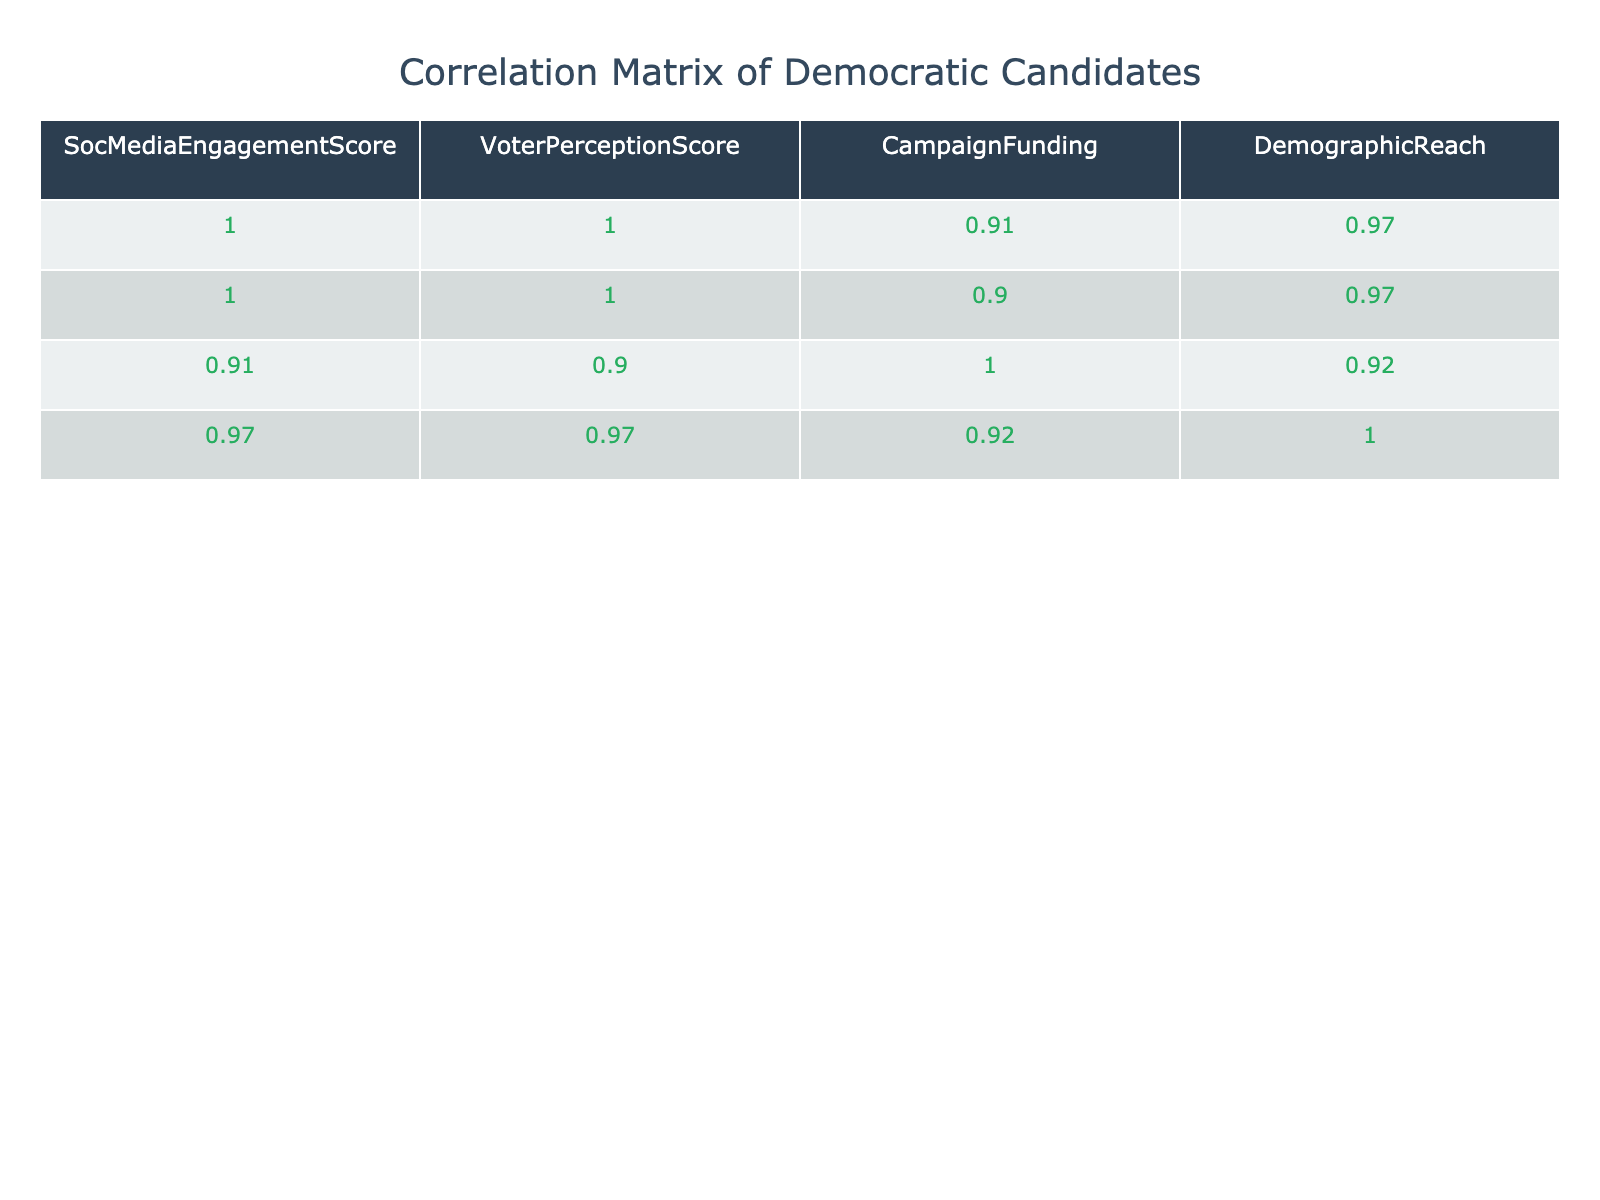What is the correlation between social media engagement score and voter perception score? The correlation value between the "SocMediaEngagementScore" and "VoterPerceptionScore" columns shows how strongly they are related. From the correlation table, we can observe that the correlation coefficient is positive and relatively high, indicating that as social media engagement increases, voter perception also tends to increase.
Answer: Positive correlation Which candidate has the highest social media engagement score? By inspecting the "SocMediaEngagementScore" column, we find that Emily Kim has the highest score of 95.
Answer: Emily Kim What is the average voter perception score of candidates with a social media engagement score above 80? Identify candidates with scores above 80: John Smith (78), Sarah Johnson (82), Emily Kim (88), Lisa Chen (80), Rachel Green (85). The total perception score is 78 + 82 + 88 + 80 + 85 = 413. There are 5 candidates, so the average is 413 / 5 = 82.6.
Answer: 82.6 Is Cory Tomczyk's campaign funding above 300,000? Looking at the "CampaignFunding" column for Cory Tomczyk, we see that the value is 250,000, which is below 300,000; thus, the statement is false.
Answer: No Which candidate has the lowest voter perception score and what is that score? The lowest score in the "VoterPerceptionScore" column can be found by inspecting each candidate's score and identifying Cory Tomczyk, who has a score of 30.
Answer: 30 What is the difference between the highest and lowest social media engagement scores in the dataset? The highest score is from Emily Kim (95) and the lowest score is from Cory Tomczyk (40). The difference is 95 - 40 = 55.
Answer: 55 Which candidate has the most favorable voter perception score relative to their social media engagement score? To find the candidate with the most favorable perception relative to engagement, we can calculate the ratio of "VoterPerceptionScore" to "SocMediaEngagementScore." The highest ratio comes from Emily Kim: 88 / 95 ≈ 0.926, indicating that she has the most favorable perception relative to her engagement score.
Answer: Emily Kim Does an increase in campaign funding correlate with a higher voter perception score? Observing the "CampaignFunding" and "VoterPerceptionScore" values, candidates with higher funding scores tend to have higher perception scores, suggesting there is a positive correlation.
Answer: Yes 